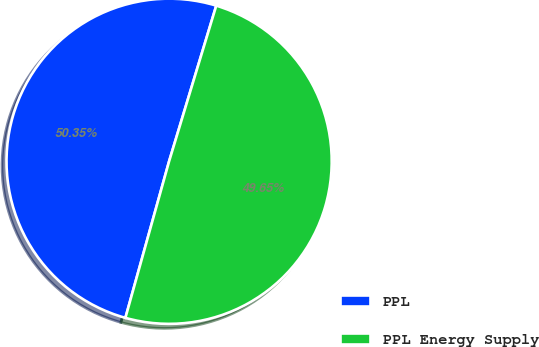Convert chart to OTSL. <chart><loc_0><loc_0><loc_500><loc_500><pie_chart><fcel>PPL<fcel>PPL Energy Supply<nl><fcel>50.35%<fcel>49.65%<nl></chart> 